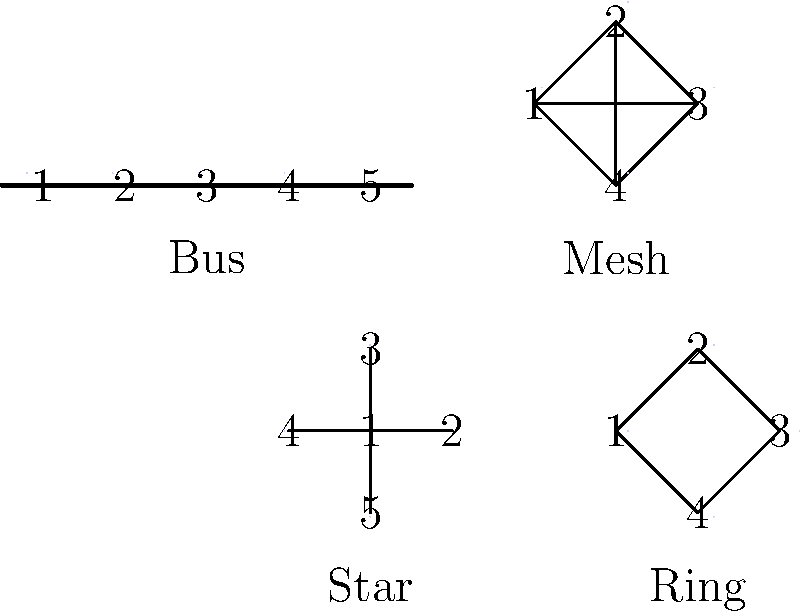In a karaoke party setting, which network topology would best represent a group of singers where everyone can communicate directly with each other, similar to how you and your spouse might interact during a sing-along session? Let's analyze each network topology in the context of a karaoke party:

1. Star Topology: In this configuration, all nodes (singers) are connected to a central node. This could represent a scenario where all singers communicate through a host or central system, but not directly with each other.

2. Bus Topology: Here, all nodes are connected to a single line. This might represent singers taking turns on a single microphone, but doesn't allow for simultaneous interaction.

3. Ring Topology: Nodes are connected in a circular fashion. This could represent singers arranged in a circle, each interacting only with those next to them.

4. Mesh Topology: In this configuration, every node is directly connected to every other node. This represents a scenario where each singer can directly communicate with all other singers simultaneously.

In a karaoke party where you and your spouse join in sing-along sessions, the ideal scenario would be one where everyone can interact freely with everyone else. This allows for harmonizing, duets, and spontaneous group performances.

The topology that best represents this scenario is the Mesh Topology. It allows for direct communication between all participants, mirroring the free-flowing nature of a group sing-along where anyone can interact with anyone else at any time.
Answer: Mesh Topology 